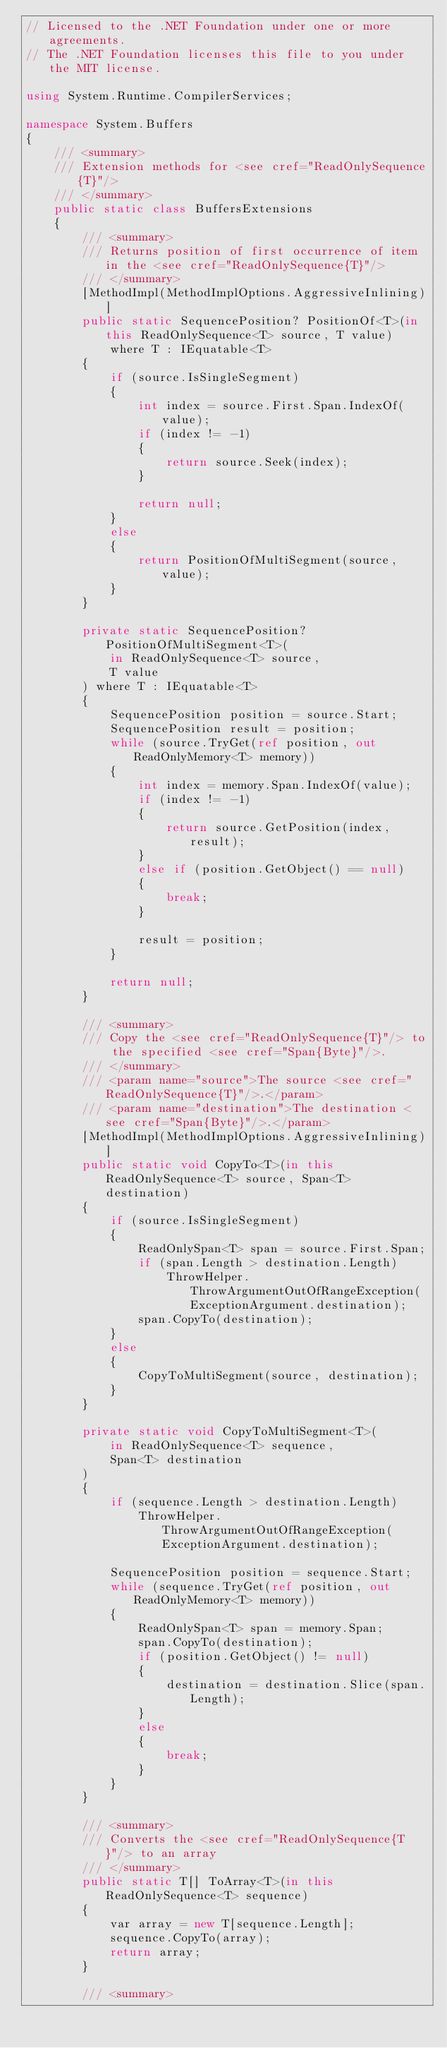<code> <loc_0><loc_0><loc_500><loc_500><_C#_>// Licensed to the .NET Foundation under one or more agreements.
// The .NET Foundation licenses this file to you under the MIT license.

using System.Runtime.CompilerServices;

namespace System.Buffers
{
    /// <summary>
    /// Extension methods for <see cref="ReadOnlySequence{T}"/>
    /// </summary>
    public static class BuffersExtensions
    {
        /// <summary>
        /// Returns position of first occurrence of item in the <see cref="ReadOnlySequence{T}"/>
        /// </summary>
        [MethodImpl(MethodImplOptions.AggressiveInlining)]
        public static SequencePosition? PositionOf<T>(in this ReadOnlySequence<T> source, T value)
            where T : IEquatable<T>
        {
            if (source.IsSingleSegment)
            {
                int index = source.First.Span.IndexOf(value);
                if (index != -1)
                {
                    return source.Seek(index);
                }

                return null;
            }
            else
            {
                return PositionOfMultiSegment(source, value);
            }
        }

        private static SequencePosition? PositionOfMultiSegment<T>(
            in ReadOnlySequence<T> source,
            T value
        ) where T : IEquatable<T>
        {
            SequencePosition position = source.Start;
            SequencePosition result = position;
            while (source.TryGet(ref position, out ReadOnlyMemory<T> memory))
            {
                int index = memory.Span.IndexOf(value);
                if (index != -1)
                {
                    return source.GetPosition(index, result);
                }
                else if (position.GetObject() == null)
                {
                    break;
                }

                result = position;
            }

            return null;
        }

        /// <summary>
        /// Copy the <see cref="ReadOnlySequence{T}"/> to the specified <see cref="Span{Byte}"/>.
        /// </summary>
        /// <param name="source">The source <see cref="ReadOnlySequence{T}"/>.</param>
        /// <param name="destination">The destination <see cref="Span{Byte}"/>.</param>
        [MethodImpl(MethodImplOptions.AggressiveInlining)]
        public static void CopyTo<T>(in this ReadOnlySequence<T> source, Span<T> destination)
        {
            if (source.IsSingleSegment)
            {
                ReadOnlySpan<T> span = source.First.Span;
                if (span.Length > destination.Length)
                    ThrowHelper.ThrowArgumentOutOfRangeException(ExceptionArgument.destination);
                span.CopyTo(destination);
            }
            else
            {
                CopyToMultiSegment(source, destination);
            }
        }

        private static void CopyToMultiSegment<T>(
            in ReadOnlySequence<T> sequence,
            Span<T> destination
        )
        {
            if (sequence.Length > destination.Length)
                ThrowHelper.ThrowArgumentOutOfRangeException(ExceptionArgument.destination);

            SequencePosition position = sequence.Start;
            while (sequence.TryGet(ref position, out ReadOnlyMemory<T> memory))
            {
                ReadOnlySpan<T> span = memory.Span;
                span.CopyTo(destination);
                if (position.GetObject() != null)
                {
                    destination = destination.Slice(span.Length);
                }
                else
                {
                    break;
                }
            }
        }

        /// <summary>
        /// Converts the <see cref="ReadOnlySequence{T}"/> to an array
        /// </summary>
        public static T[] ToArray<T>(in this ReadOnlySequence<T> sequence)
        {
            var array = new T[sequence.Length];
            sequence.CopyTo(array);
            return array;
        }

        /// <summary></code> 